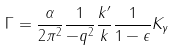Convert formula to latex. <formula><loc_0><loc_0><loc_500><loc_500>\Gamma = \frac { \alpha } { 2 \pi ^ { 2 } } \frac { 1 } { - q ^ { 2 } } \frac { k ^ { \prime } } { k } \frac { 1 } { 1 - \epsilon } K _ { \gamma }</formula> 